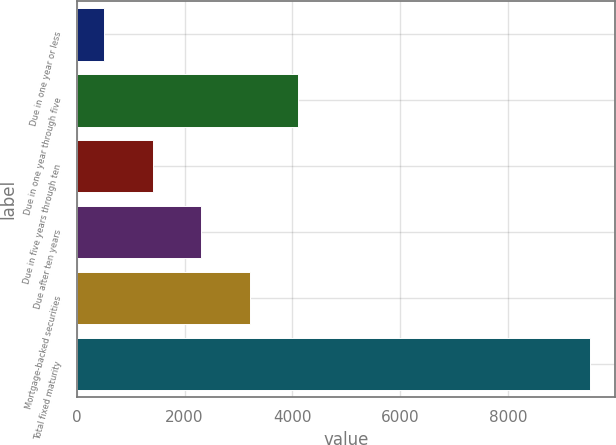Convert chart to OTSL. <chart><loc_0><loc_0><loc_500><loc_500><bar_chart><fcel>Due in one year or less<fcel>Due in one year through five<fcel>Due in five years through ten<fcel>Due after ten years<fcel>Mortgage-backed securities<fcel>Total fixed maturity<nl><fcel>502<fcel>4112<fcel>1409<fcel>2310<fcel>3211<fcel>9512<nl></chart> 